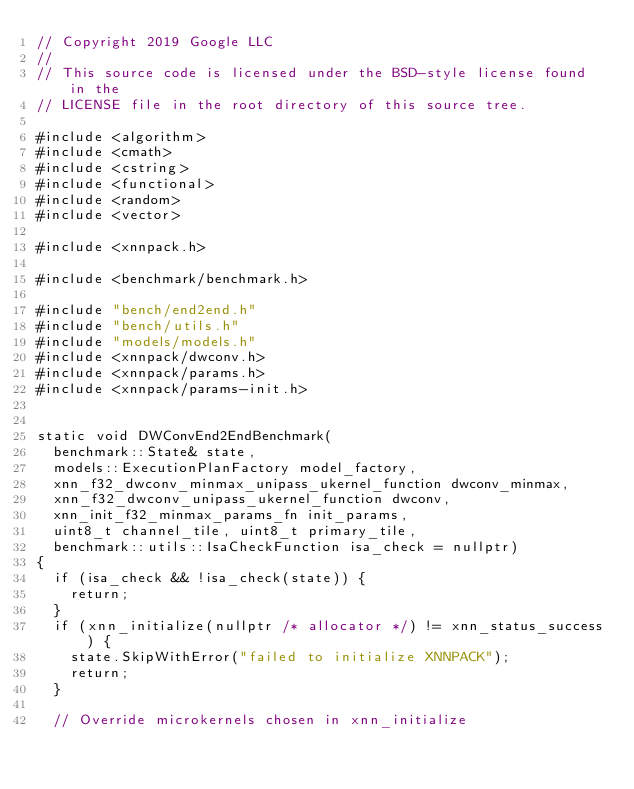<code> <loc_0><loc_0><loc_500><loc_500><_C++_>// Copyright 2019 Google LLC
//
// This source code is licensed under the BSD-style license found in the
// LICENSE file in the root directory of this source tree.

#include <algorithm>
#include <cmath>
#include <cstring>
#include <functional>
#include <random>
#include <vector>

#include <xnnpack.h>

#include <benchmark/benchmark.h>

#include "bench/end2end.h"
#include "bench/utils.h"
#include "models/models.h"
#include <xnnpack/dwconv.h>
#include <xnnpack/params.h>
#include <xnnpack/params-init.h>


static void DWConvEnd2EndBenchmark(
  benchmark::State& state,
  models::ExecutionPlanFactory model_factory,
  xnn_f32_dwconv_minmax_unipass_ukernel_function dwconv_minmax,
  xnn_f32_dwconv_unipass_ukernel_function dwconv,
  xnn_init_f32_minmax_params_fn init_params,
  uint8_t channel_tile, uint8_t primary_tile,
  benchmark::utils::IsaCheckFunction isa_check = nullptr)
{
  if (isa_check && !isa_check(state)) {
    return;
  }
  if (xnn_initialize(nullptr /* allocator */) != xnn_status_success) {
    state.SkipWithError("failed to initialize XNNPACK");
    return;
  }

  // Override microkernels chosen in xnn_initialize</code> 